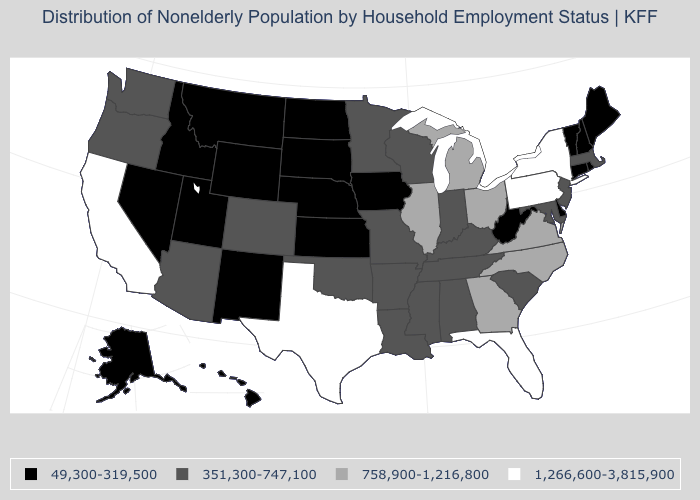Name the states that have a value in the range 49,300-319,500?
Quick response, please. Alaska, Connecticut, Delaware, Hawaii, Idaho, Iowa, Kansas, Maine, Montana, Nebraska, Nevada, New Hampshire, New Mexico, North Dakota, Rhode Island, South Dakota, Utah, Vermont, West Virginia, Wyoming. Which states have the lowest value in the USA?
Keep it brief. Alaska, Connecticut, Delaware, Hawaii, Idaho, Iowa, Kansas, Maine, Montana, Nebraska, Nevada, New Hampshire, New Mexico, North Dakota, Rhode Island, South Dakota, Utah, Vermont, West Virginia, Wyoming. Name the states that have a value in the range 49,300-319,500?
Write a very short answer. Alaska, Connecticut, Delaware, Hawaii, Idaho, Iowa, Kansas, Maine, Montana, Nebraska, Nevada, New Hampshire, New Mexico, North Dakota, Rhode Island, South Dakota, Utah, Vermont, West Virginia, Wyoming. How many symbols are there in the legend?
Concise answer only. 4. Which states hav the highest value in the Northeast?
Concise answer only. New York, Pennsylvania. Does the map have missing data?
Answer briefly. No. Name the states that have a value in the range 351,300-747,100?
Write a very short answer. Alabama, Arizona, Arkansas, Colorado, Indiana, Kentucky, Louisiana, Maryland, Massachusetts, Minnesota, Mississippi, Missouri, New Jersey, Oklahoma, Oregon, South Carolina, Tennessee, Washington, Wisconsin. What is the value of Oregon?
Quick response, please. 351,300-747,100. How many symbols are there in the legend?
Answer briefly. 4. What is the value of Rhode Island?
Write a very short answer. 49,300-319,500. What is the value of California?
Short answer required. 1,266,600-3,815,900. What is the highest value in the USA?
Short answer required. 1,266,600-3,815,900. What is the highest value in the USA?
Keep it brief. 1,266,600-3,815,900. What is the value of Wisconsin?
Quick response, please. 351,300-747,100. What is the highest value in the USA?
Give a very brief answer. 1,266,600-3,815,900. 